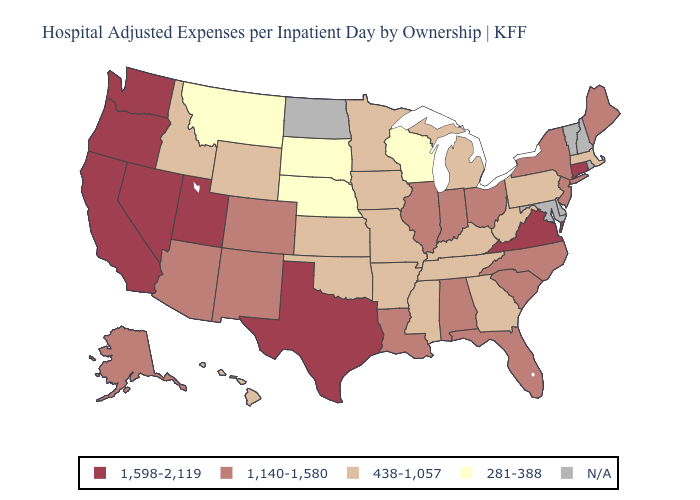Among the states that border Michigan , does Ohio have the lowest value?
Write a very short answer. No. What is the value of Indiana?
Quick response, please. 1,140-1,580. Which states have the highest value in the USA?
Quick response, please. California, Connecticut, Nevada, Oregon, Texas, Utah, Virginia, Washington. What is the lowest value in the Northeast?
Write a very short answer. 438-1,057. What is the highest value in the West ?
Keep it brief. 1,598-2,119. Is the legend a continuous bar?
Short answer required. No. Is the legend a continuous bar?
Short answer required. No. What is the value of Maryland?
Quick response, please. N/A. Name the states that have a value in the range N/A?
Keep it brief. Delaware, Maryland, New Hampshire, North Dakota, Rhode Island, Vermont. Does Pennsylvania have the highest value in the Northeast?
Give a very brief answer. No. What is the value of Kansas?
Quick response, please. 438-1,057. Name the states that have a value in the range 1,140-1,580?
Give a very brief answer. Alabama, Alaska, Arizona, Colorado, Florida, Illinois, Indiana, Louisiana, Maine, New Jersey, New Mexico, New York, North Carolina, Ohio, South Carolina. 